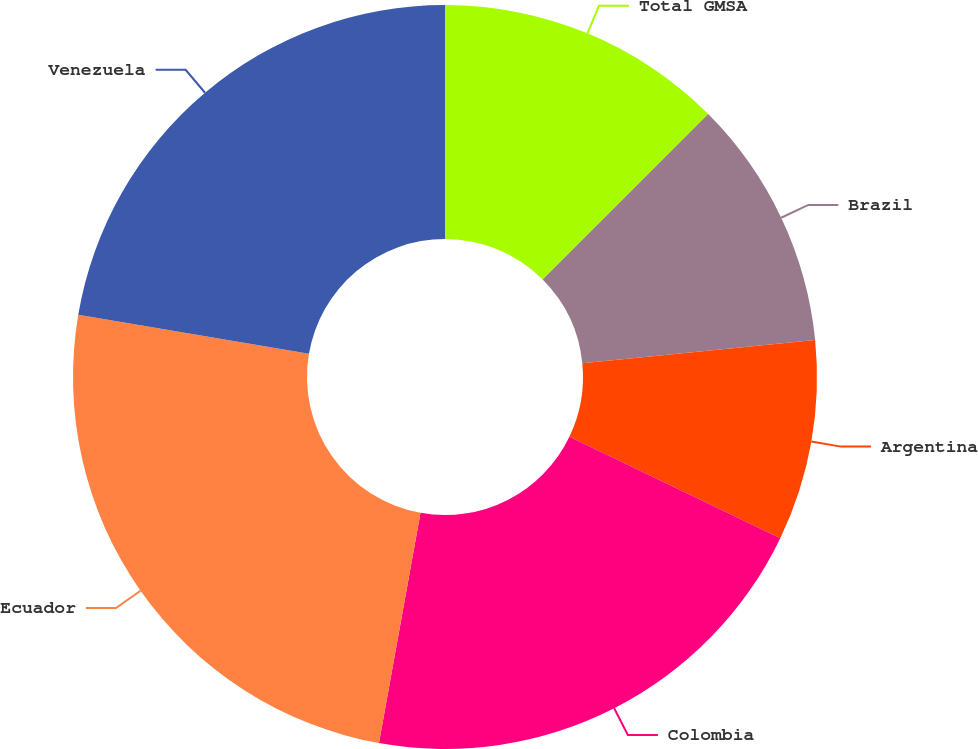Convert chart to OTSL. <chart><loc_0><loc_0><loc_500><loc_500><pie_chart><fcel>Total GMSA<fcel>Brazil<fcel>Argentina<fcel>Colombia<fcel>Ecuador<fcel>Venezuela<nl><fcel>12.51%<fcel>10.9%<fcel>8.72%<fcel>20.71%<fcel>24.84%<fcel>22.32%<nl></chart> 